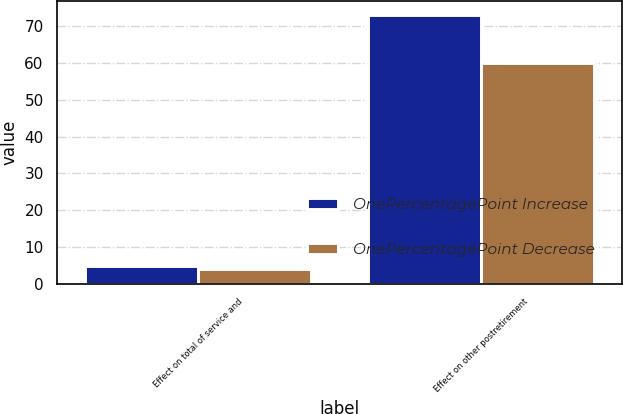<chart> <loc_0><loc_0><loc_500><loc_500><stacked_bar_chart><ecel><fcel>Effect on total of service and<fcel>Effect on other postretirement<nl><fcel>OnePercentagePoint Increase<fcel>5<fcel>73<nl><fcel>OnePercentagePoint Decrease<fcel>4<fcel>60<nl></chart> 